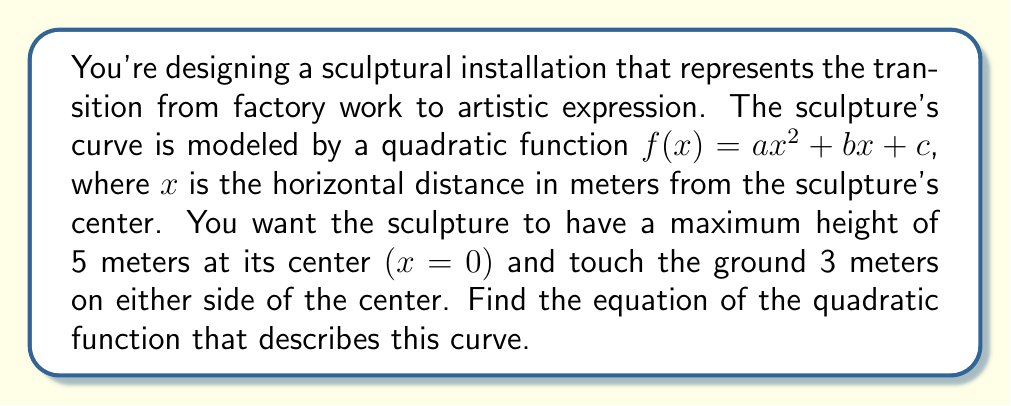Can you solve this math problem? Let's approach this step-by-step:

1) We know that the vertex of the parabola is at $(0, 5)$, as the maximum height of 5 meters occurs at the center $(x=0)$. This means our function will be in the form:

   $f(x) = a(x-0)^2 + 5$

2) We also know that the curve touches the ground 3 meters on either side of the center. This means $f(3) = f(-3) = 0$. Let's use $f(3) = 0$:

   $0 = a(3-0)^2 + 5$
   $0 = 9a + 5$
   $-5 = 9a$
   $a = -\frac{5}{9}$

3) Now that we have $a$, we can write our complete function:

   $f(x) = -\frac{5}{9}x^2 + 5$

4) To verify, let's check if $f(-3) = 0$:

   $f(-3) = -\frac{5}{9}(-3)^2 + 5 = -\frac{5}{9}(9) + 5 = -5 + 5 = 0$

   This confirms our function is correct.

5) To put it in standard form $(ax^2 + bx + c)$, we expand:

   $f(x) = -\frac{5}{9}x^2 + 0x + 5$
Answer: $f(x) = -\frac{5}{9}x^2 + 5$ 